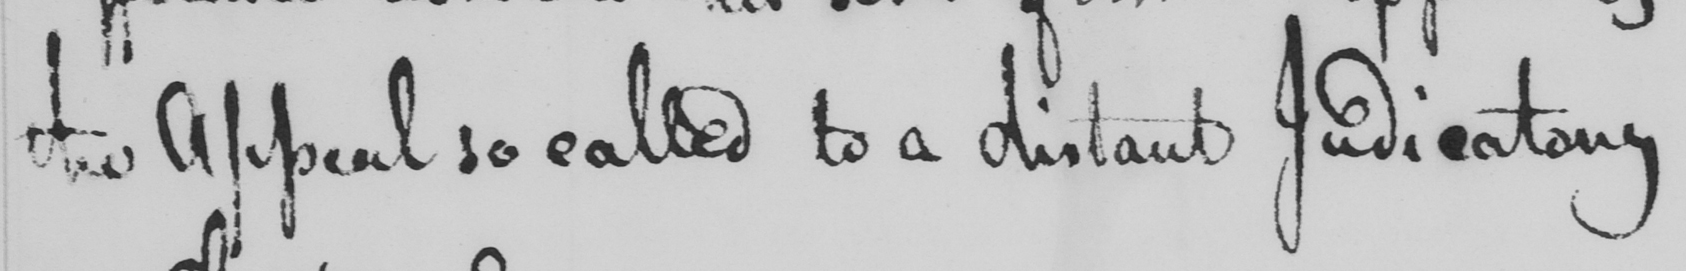Can you tell me what this handwritten text says? the Appeal so called to a distant Judicatory 